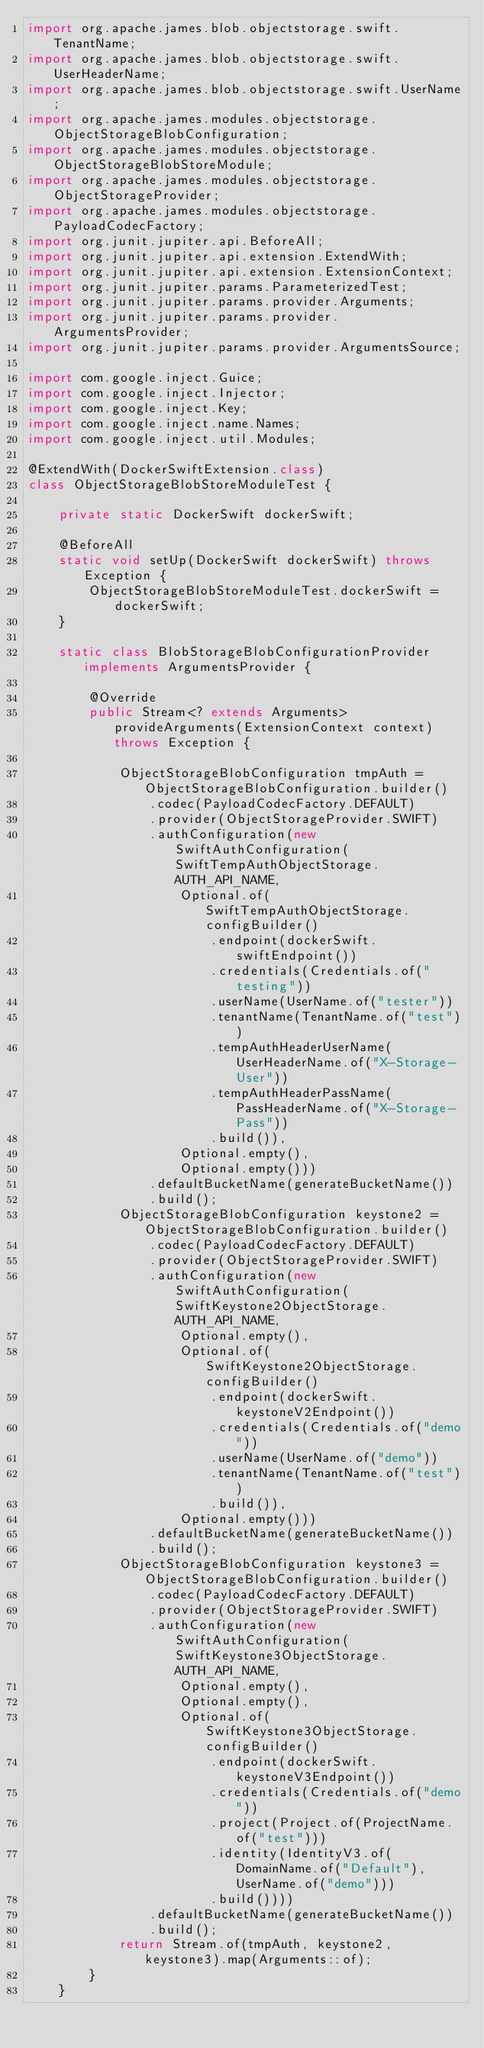<code> <loc_0><loc_0><loc_500><loc_500><_Java_>import org.apache.james.blob.objectstorage.swift.TenantName;
import org.apache.james.blob.objectstorage.swift.UserHeaderName;
import org.apache.james.blob.objectstorage.swift.UserName;
import org.apache.james.modules.objectstorage.ObjectStorageBlobConfiguration;
import org.apache.james.modules.objectstorage.ObjectStorageBlobStoreModule;
import org.apache.james.modules.objectstorage.ObjectStorageProvider;
import org.apache.james.modules.objectstorage.PayloadCodecFactory;
import org.junit.jupiter.api.BeforeAll;
import org.junit.jupiter.api.extension.ExtendWith;
import org.junit.jupiter.api.extension.ExtensionContext;
import org.junit.jupiter.params.ParameterizedTest;
import org.junit.jupiter.params.provider.Arguments;
import org.junit.jupiter.params.provider.ArgumentsProvider;
import org.junit.jupiter.params.provider.ArgumentsSource;

import com.google.inject.Guice;
import com.google.inject.Injector;
import com.google.inject.Key;
import com.google.inject.name.Names;
import com.google.inject.util.Modules;

@ExtendWith(DockerSwiftExtension.class)
class ObjectStorageBlobStoreModuleTest {

    private static DockerSwift dockerSwift;

    @BeforeAll
    static void setUp(DockerSwift dockerSwift) throws Exception {
        ObjectStorageBlobStoreModuleTest.dockerSwift = dockerSwift;
    }

    static class BlobStorageBlobConfigurationProvider implements ArgumentsProvider {

        @Override
        public Stream<? extends Arguments> provideArguments(ExtensionContext context) throws Exception {

            ObjectStorageBlobConfiguration tmpAuth = ObjectStorageBlobConfiguration.builder()
                .codec(PayloadCodecFactory.DEFAULT)
                .provider(ObjectStorageProvider.SWIFT)
                .authConfiguration(new SwiftAuthConfiguration(SwiftTempAuthObjectStorage.AUTH_API_NAME,
                    Optional.of(SwiftTempAuthObjectStorage.configBuilder()
                        .endpoint(dockerSwift.swiftEndpoint())
                        .credentials(Credentials.of("testing"))
                        .userName(UserName.of("tester"))
                        .tenantName(TenantName.of("test"))
                        .tempAuthHeaderUserName(UserHeaderName.of("X-Storage-User"))
                        .tempAuthHeaderPassName(PassHeaderName.of("X-Storage-Pass"))
                        .build()),
                    Optional.empty(),
                    Optional.empty()))
                .defaultBucketName(generateBucketName())
                .build();
            ObjectStorageBlobConfiguration keystone2 = ObjectStorageBlobConfiguration.builder()
                .codec(PayloadCodecFactory.DEFAULT)
                .provider(ObjectStorageProvider.SWIFT)
                .authConfiguration(new SwiftAuthConfiguration(SwiftKeystone2ObjectStorage.AUTH_API_NAME,
                    Optional.empty(),
                    Optional.of(SwiftKeystone2ObjectStorage.configBuilder()
                        .endpoint(dockerSwift.keystoneV2Endpoint())
                        .credentials(Credentials.of("demo"))
                        .userName(UserName.of("demo"))
                        .tenantName(TenantName.of("test"))
                        .build()),
                    Optional.empty()))
                .defaultBucketName(generateBucketName())
                .build();
            ObjectStorageBlobConfiguration keystone3 = ObjectStorageBlobConfiguration.builder()
                .codec(PayloadCodecFactory.DEFAULT)
                .provider(ObjectStorageProvider.SWIFT)
                .authConfiguration(new SwiftAuthConfiguration(SwiftKeystone3ObjectStorage.AUTH_API_NAME,
                    Optional.empty(),
                    Optional.empty(),
                    Optional.of(SwiftKeystone3ObjectStorage.configBuilder()
                        .endpoint(dockerSwift.keystoneV3Endpoint())
                        .credentials(Credentials.of("demo"))
                        .project(Project.of(ProjectName.of("test")))
                        .identity(IdentityV3.of(DomainName.of("Default"), UserName.of("demo")))
                        .build())))
                .defaultBucketName(generateBucketName())
                .build();
            return Stream.of(tmpAuth, keystone2, keystone3).map(Arguments::of);
        }
    }
</code> 